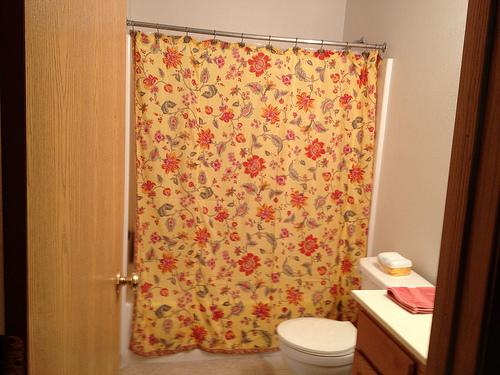Question: what color are the flowers on the curtain?
Choices:
A. Pink.
B. Red.
C. Blue.
D. Purple.
Answer with the letter. Answer: B Question: who is the subject of the photo?
Choices:
A. The bathroom.
B. The man.
C. The woman.
D. The children.
Answer with the letter. Answer: A Question: why is this photo illuminated?
Choices:
A. Flash.
B. The bathroom light.
C. The sun.
D. Daylight.
Answer with the letter. Answer: B Question: what color is the curtain?
Choices:
A. White.
B. Yellow.
C. Black.
D. Red.
Answer with the letter. Answer: B 